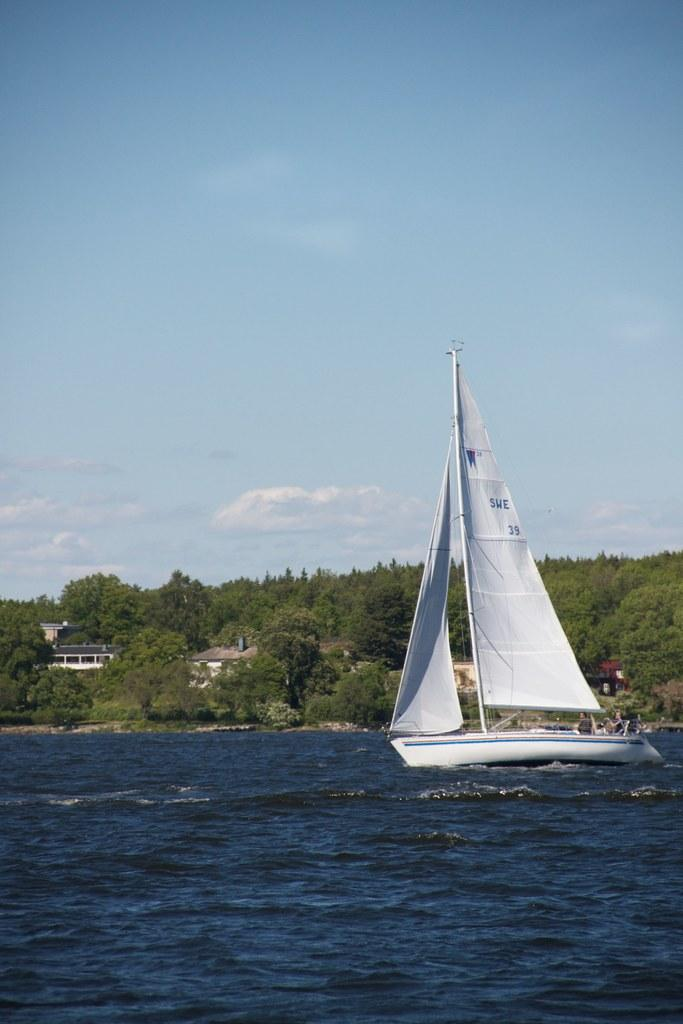What is the main subject of the image? The main subject of the image is a ship. Are there any people on the ship? Yes, there are people on the ship. What is the ship doing in the image? The ship is sailing on the water. What else can be seen in the image besides the ship? There are houses, trees, a red colored object, and the sky visible in the image. What is the condition of the sky in the image? The sky is visible in the image, and there are clouds present. What type of wine is being served on the ship in the image? There is no wine present in the image; it features a ship sailing on the water with people on board. What advice is being given to the people on the ship in the image? There is no indication in the image that any advice is being given to the people on the ship. 